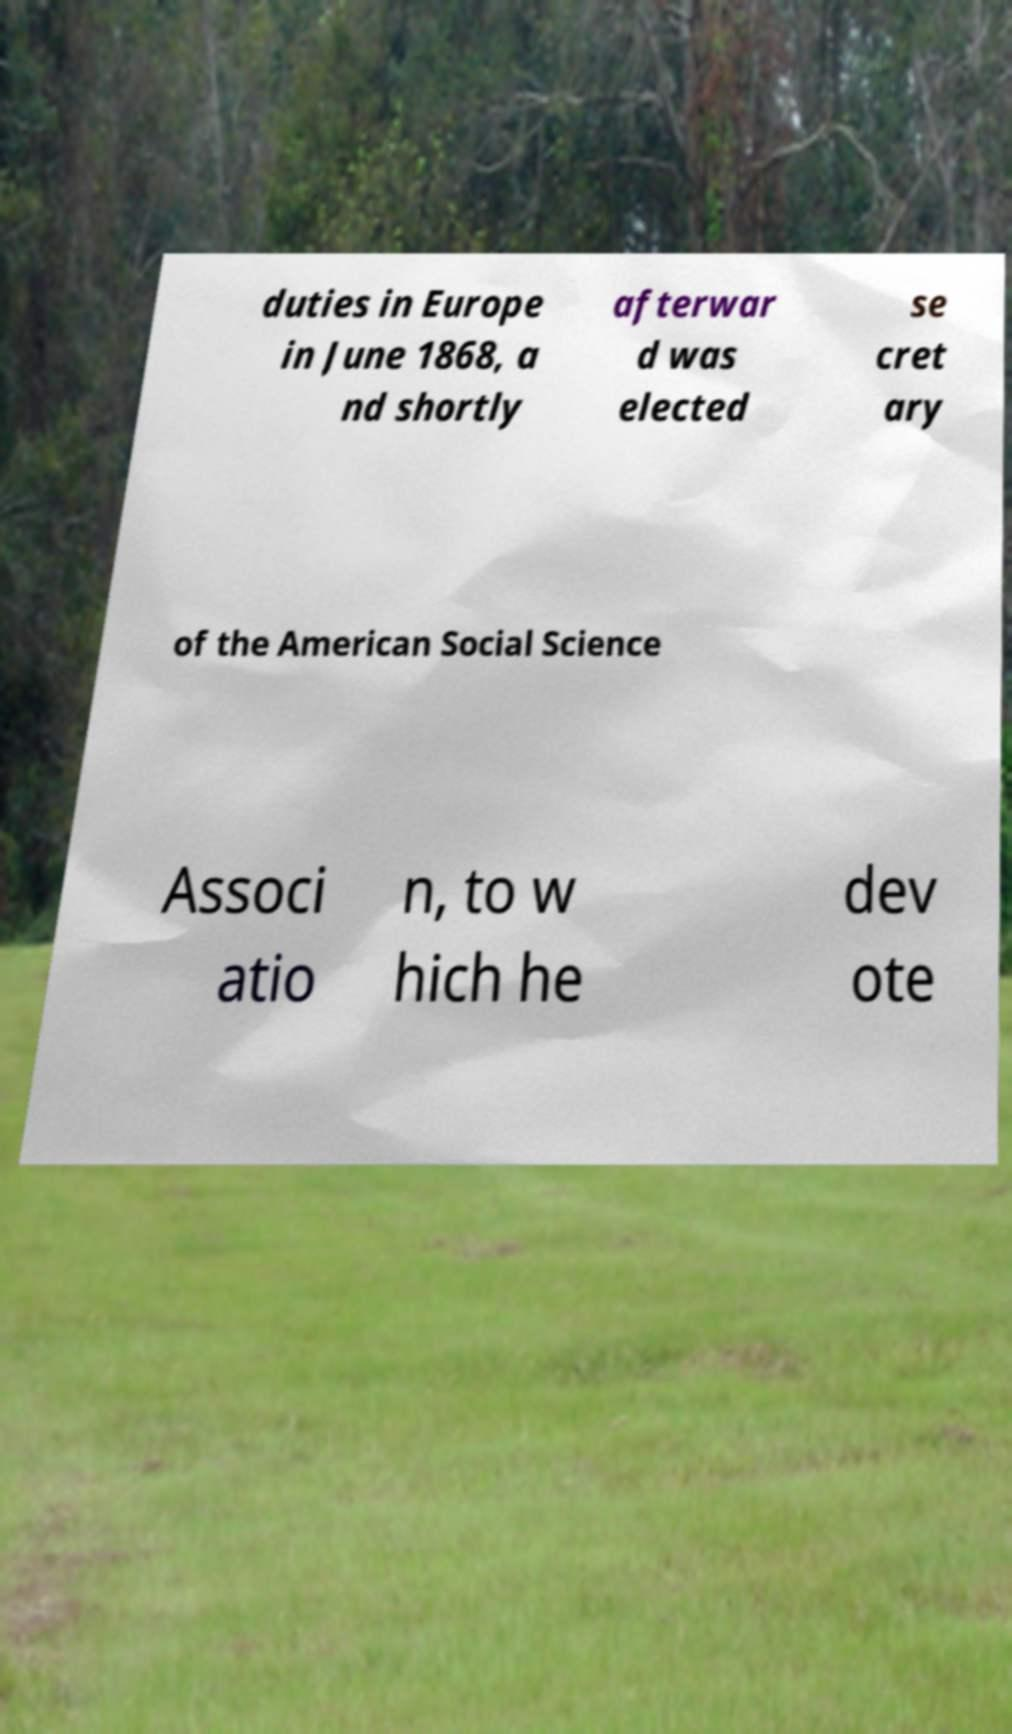Please read and relay the text visible in this image. What does it say? duties in Europe in June 1868, a nd shortly afterwar d was elected se cret ary of the American Social Science Associ atio n, to w hich he dev ote 